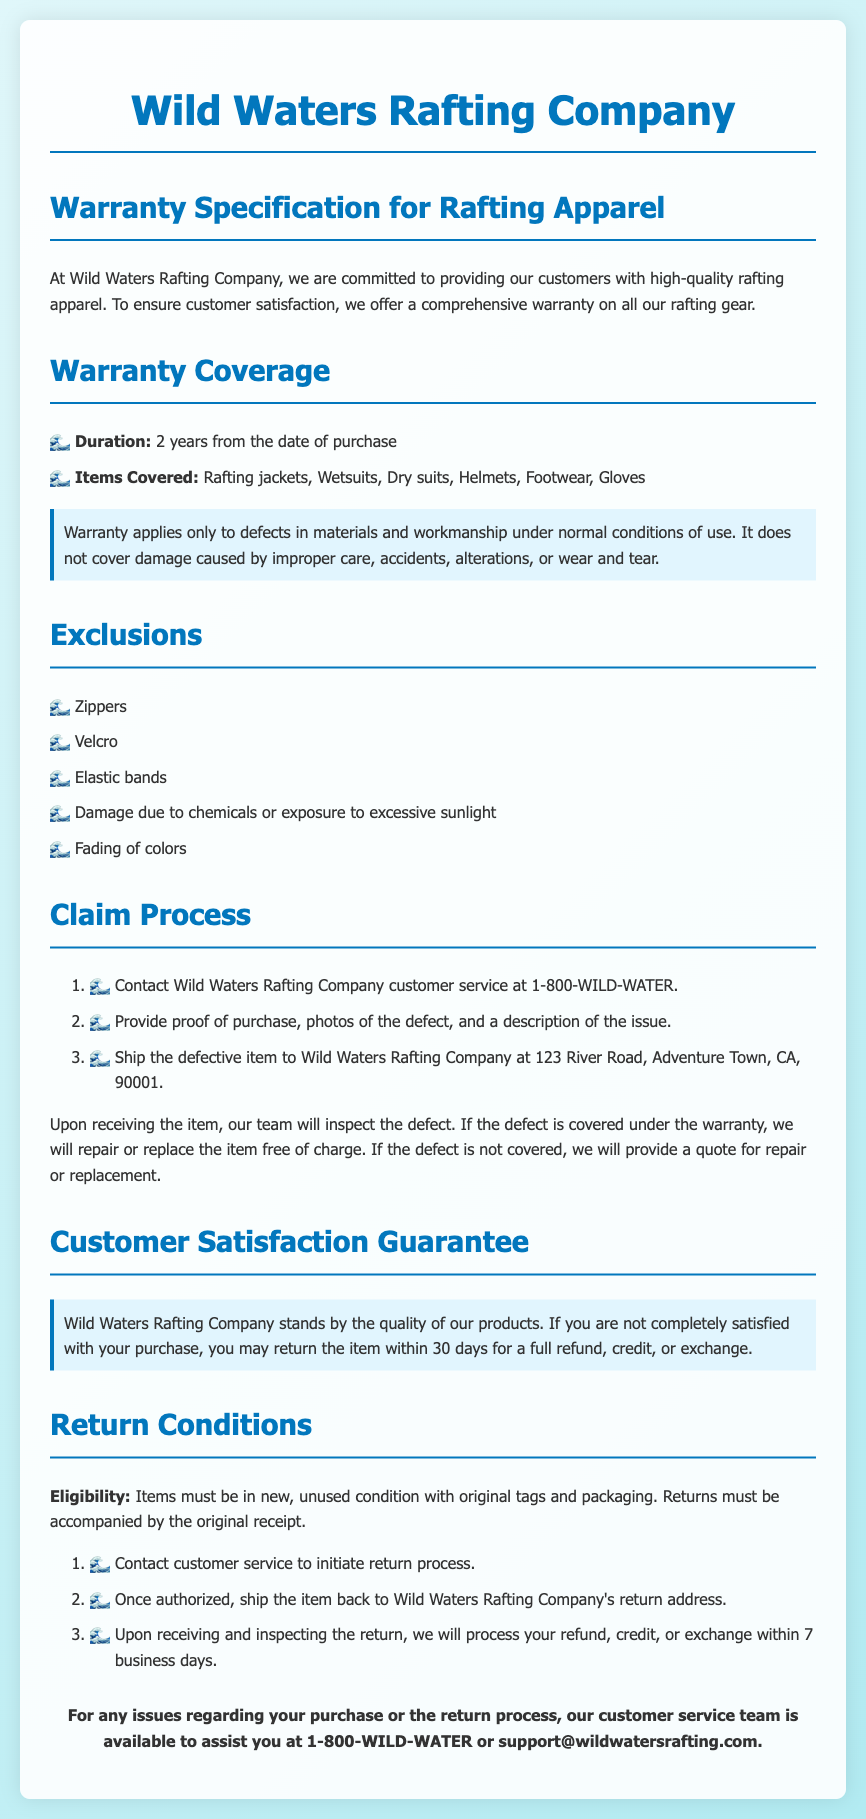What is the warranty duration? The warranty duration is specified as 2 years from the date of purchase.
Answer: 2 years What items are covered under the warranty? The items covered are listed as rafting jackets, wetsuits, dry suits, helmets, footwear, and gloves.
Answer: Rafting jackets, Wetsuits, Dry suits, Helmets, Footwear, Gloves What is excluded from the warranty? The exclusions listed include zippers, Velcro, elastic bands, chemical damage, and fading of colors.
Answer: Zippers, Velcro, Elastic bands, Damage due to chemicals or exposure to excessive sunlight, Fading of colors How long do customers have to return an item for a full refund? The document states that customers may return the item within 30 days for a full refund, credit, or exchange.
Answer: 30 days What must items be in to be eligible for return? Eligibility requires items to be in new, unused condition with original tags and packaging.
Answer: New, unused condition What is the first step in the warranty claim process? The first step in the claim process is to contact Wild Waters Rafting Company's customer service at a specified phone number.
Answer: Contact customer service What happens if a defect is not covered under the warranty? If the defect is not covered, the company will provide a quote for repair or replacement.
Answer: Provide a quote How soon will the company process a refund after receiving a return? The document specifies that refunds will be processed within 7 business days after receiving and inspecting the return.
Answer: 7 business days 